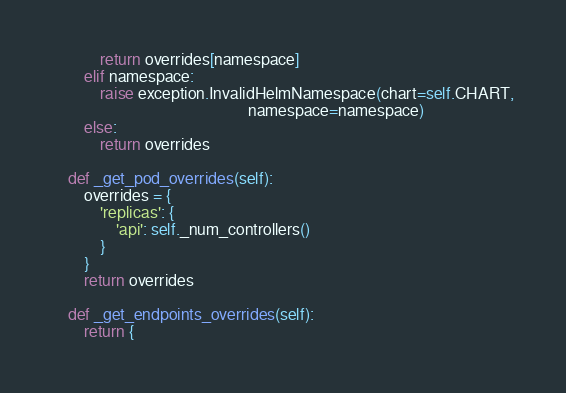Convert code to text. <code><loc_0><loc_0><loc_500><loc_500><_Python_>            return overrides[namespace]
        elif namespace:
            raise exception.InvalidHelmNamespace(chart=self.CHART,
                                                 namespace=namespace)
        else:
            return overrides

    def _get_pod_overrides(self):
        overrides = {
            'replicas': {
                'api': self._num_controllers()
            }
        }
        return overrides

    def _get_endpoints_overrides(self):
        return {</code> 